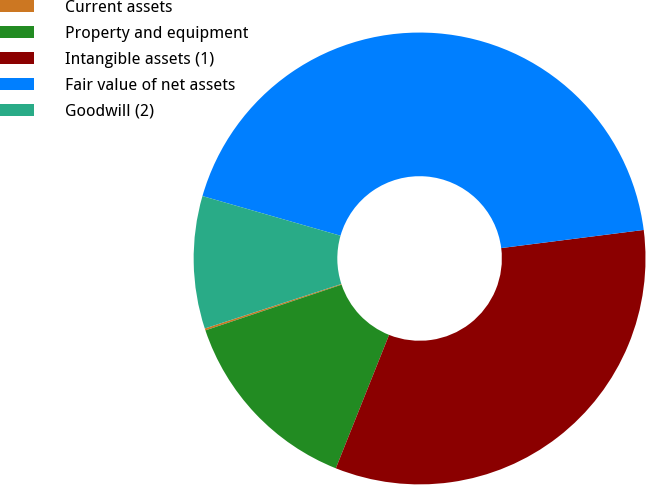<chart> <loc_0><loc_0><loc_500><loc_500><pie_chart><fcel>Current assets<fcel>Property and equipment<fcel>Intangible assets (1)<fcel>Fair value of net assets<fcel>Goodwill (2)<nl><fcel>0.14%<fcel>13.8%<fcel>33.06%<fcel>43.53%<fcel>9.47%<nl></chart> 